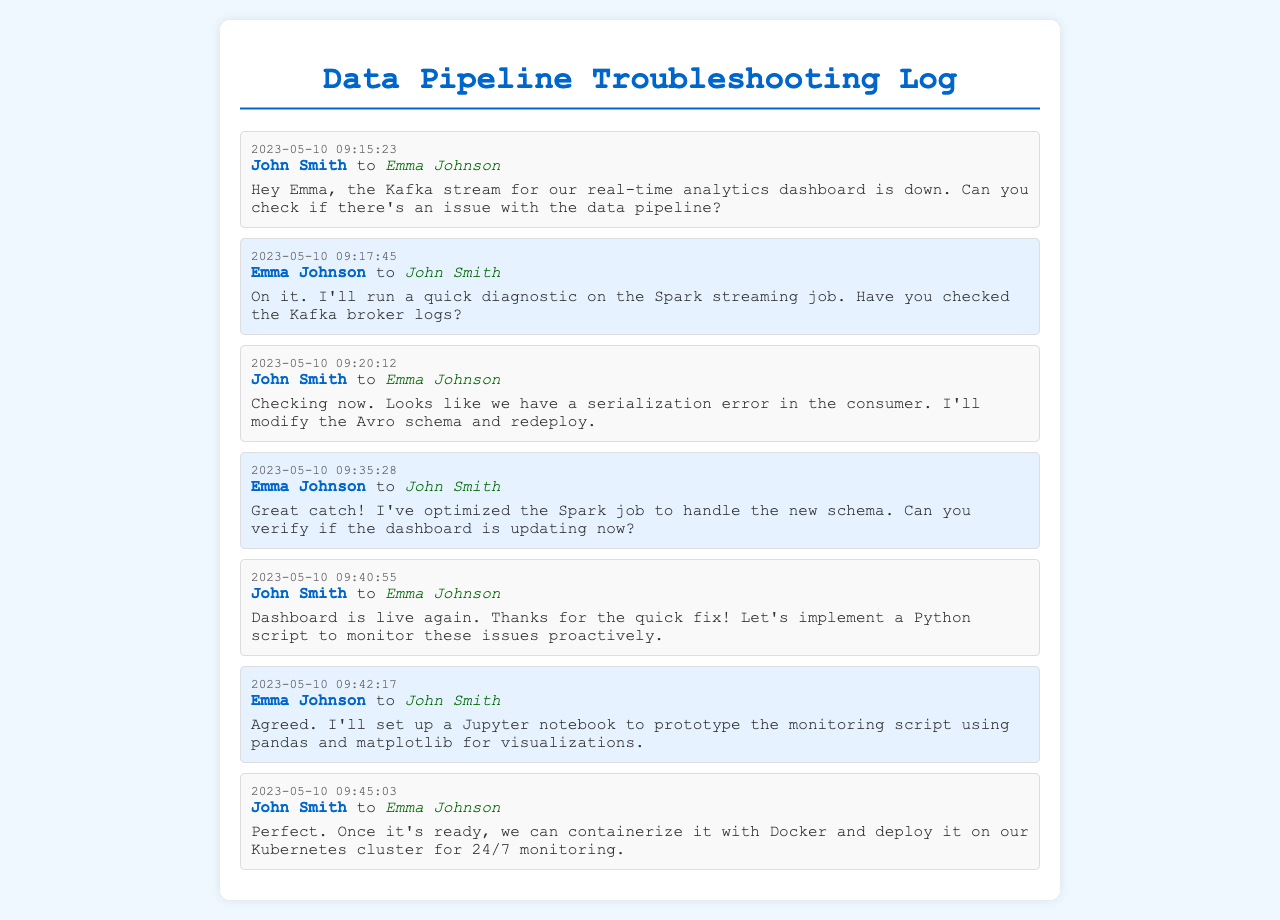What is the date of the first message? The first message in the log is dated May 10, 2023.
Answer: May 10, 2023 Who reported the Kafka stream issue? The message logs indicate that John Smith reported the issue with the Kafka stream.
Answer: John Smith What is the error identified in the consumer? John Smith mentions a serialization error in the consumer during the conversation.
Answer: Serialization error What action did Emma Johnson take regarding the Spark job? Emma Johnson optimized the Spark job to handle the new schema based on the interaction.
Answer: Optimized What tool will Emma use to prototype the monitoring script? Emma will set up a Jupyter notebook for prototyping the monitoring script.
Answer: Jupyter notebook How did the dashboard status change after troubleshooting? After resolving the issues, John Smith confirms that the dashboard is live again.
Answer: Live again 